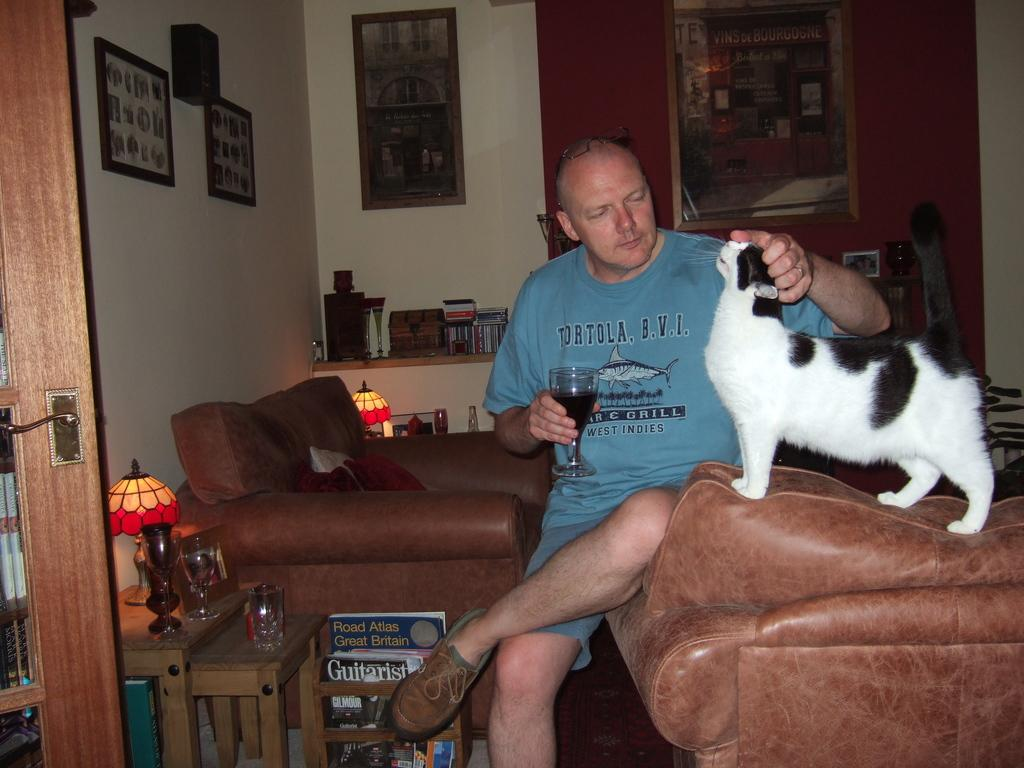<image>
Relay a brief, clear account of the picture shown. a man with a Tortola shirt on petting his cat 